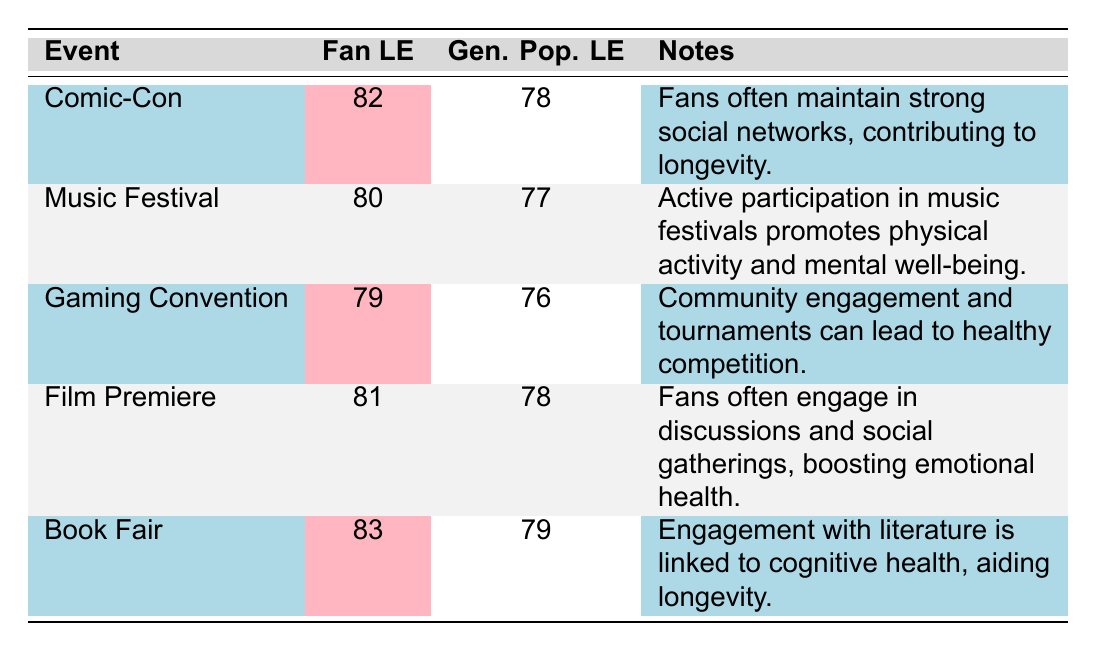What is the life expectancy of fans attending Comic-Con? The table indicates that the fan life expectancy for Comic-Con is 82.
Answer: 82 What is the difference between the life expectancy of fans and the general population at music festivals? At music festivals, the life expectancy of fans is 80 and that of the general population is 77. Therefore, the difference is 80 - 77 = 3.
Answer: 3 Is the life expectancy of fans attending a book fair higher than that of the general population attending the same event? According to the table, the fan life expectancy at book fairs is 83 and the general population's life expectancy is 79. Since 83 is greater than 79, the answer is yes.
Answer: Yes What is the average life expectancy of fans across all events listed? To find the average fan life expectancy, we need to sum the values: 82 + 80 + 79 + 81 + 83 = 405. Then divide by the number of events, which is 5: 405/5 = 81.
Answer: 81 Which event has the highest life expectancy for fans, and what is that value? By examining the fan life expectancy values: 82, 80, 79, 81, and 83, it's clear that the highest value is 83 at the book fair.
Answer: 83 